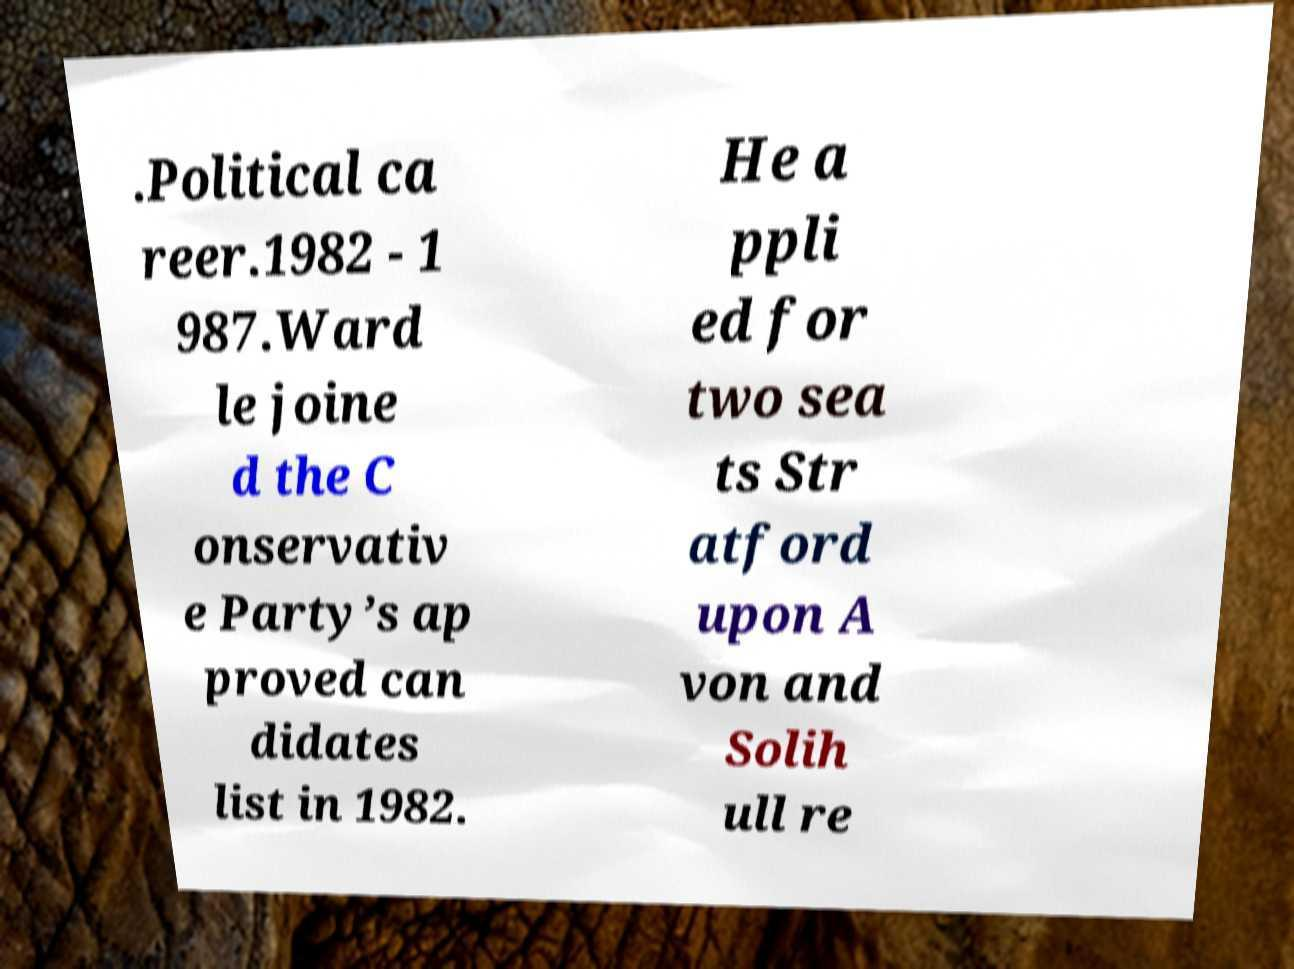Please read and relay the text visible in this image. What does it say? .Political ca reer.1982 - 1 987.Ward le joine d the C onservativ e Party’s ap proved can didates list in 1982. He a ppli ed for two sea ts Str atford upon A von and Solih ull re 